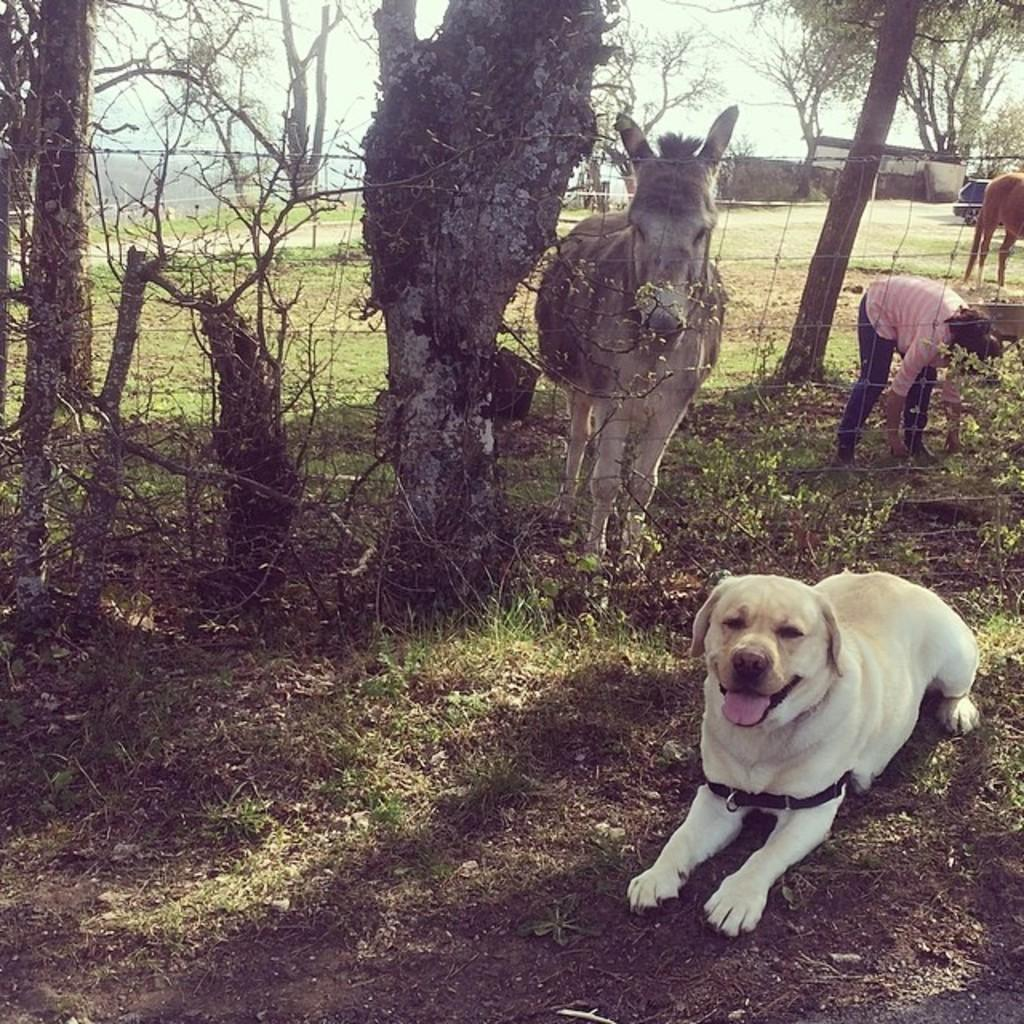What is located on the ground in the image? There are animals on the ground in the image. What can be seen in the distance in the image? The sky is visible in the background of the image, along with trees and shredded leaves. What type of trade is happening between the animals in the image? There is no indication of any trade happening between the animals in the image. How do the animals grip the ground in the image? The image does not show the animals gripping the ground, so it cannot be determined from the image. 